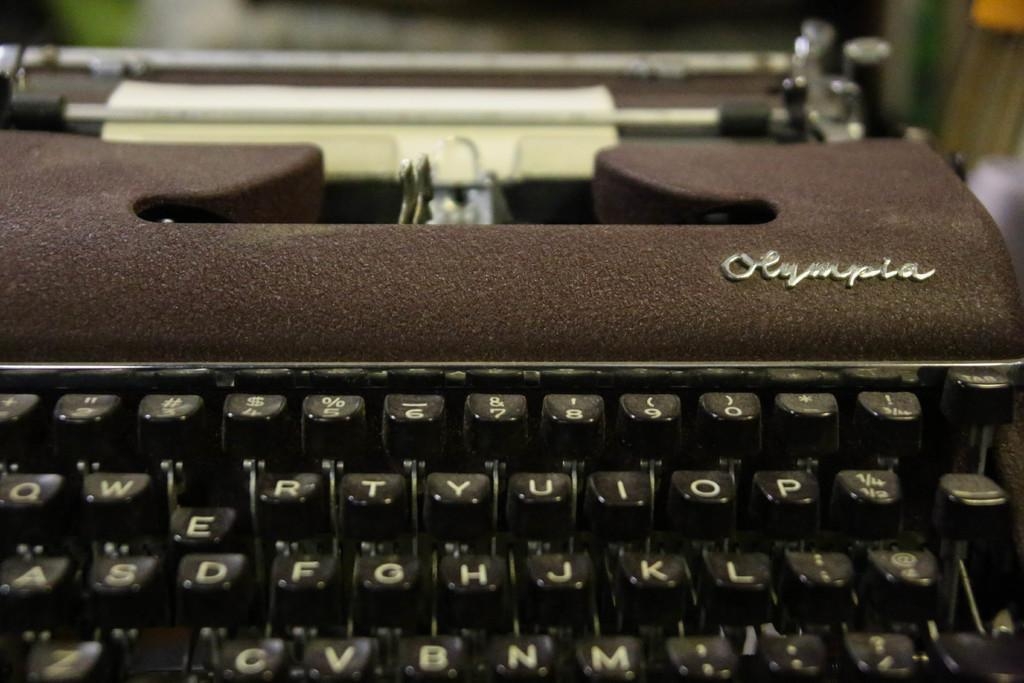<image>
Give a short and clear explanation of the subsequent image. A sheet is paper is rolled into the roller of an Olympia typewriter. 